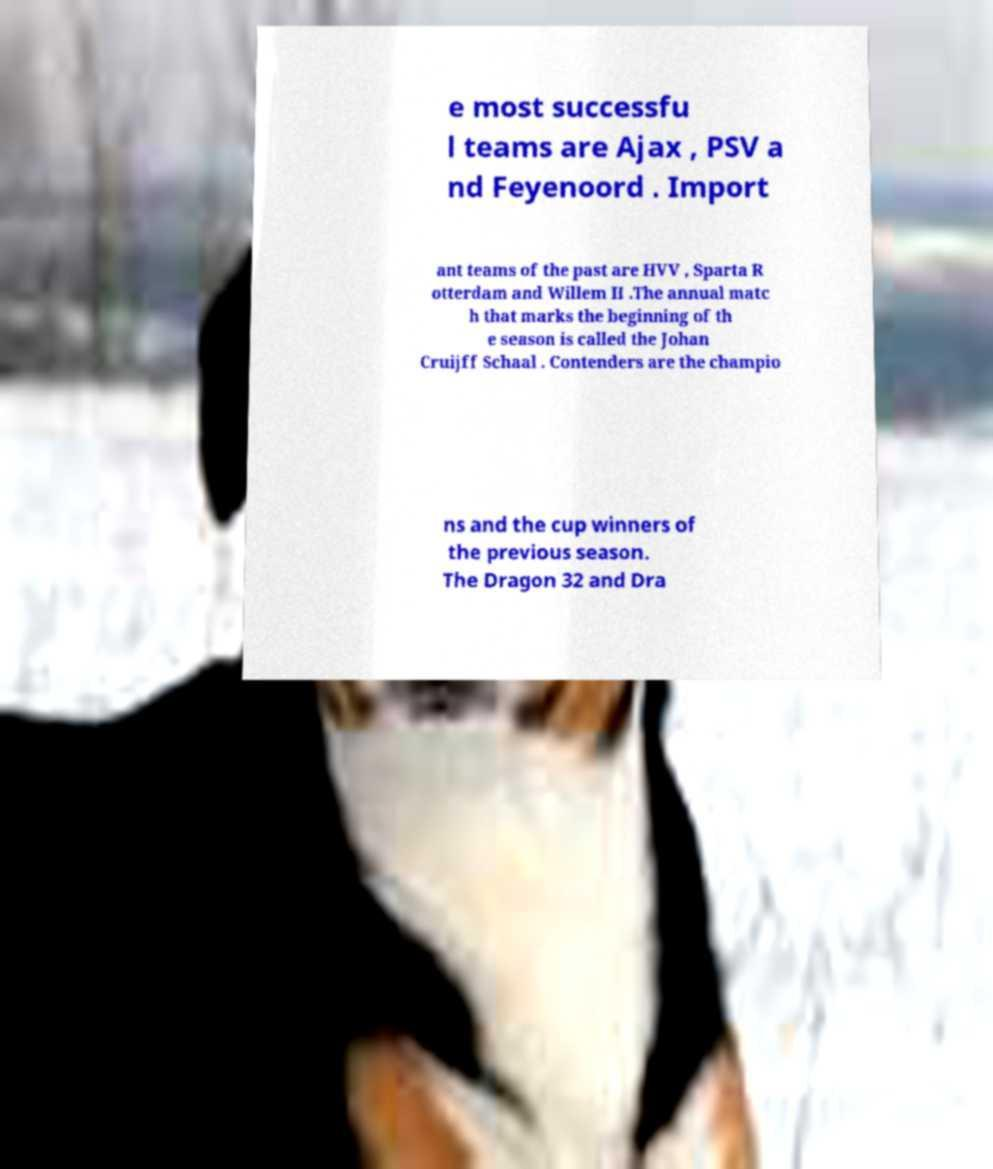For documentation purposes, I need the text within this image transcribed. Could you provide that? e most successfu l teams are Ajax , PSV a nd Feyenoord . Import ant teams of the past are HVV , Sparta R otterdam and Willem II .The annual matc h that marks the beginning of th e season is called the Johan Cruijff Schaal . Contenders are the champio ns and the cup winners of the previous season. The Dragon 32 and Dra 